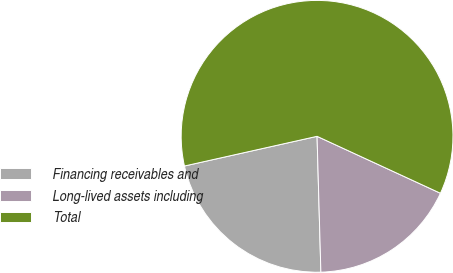Convert chart. <chart><loc_0><loc_0><loc_500><loc_500><pie_chart><fcel>Financing receivables and<fcel>Long-lived assets including<fcel>Total<nl><fcel>21.94%<fcel>17.67%<fcel>60.38%<nl></chart> 